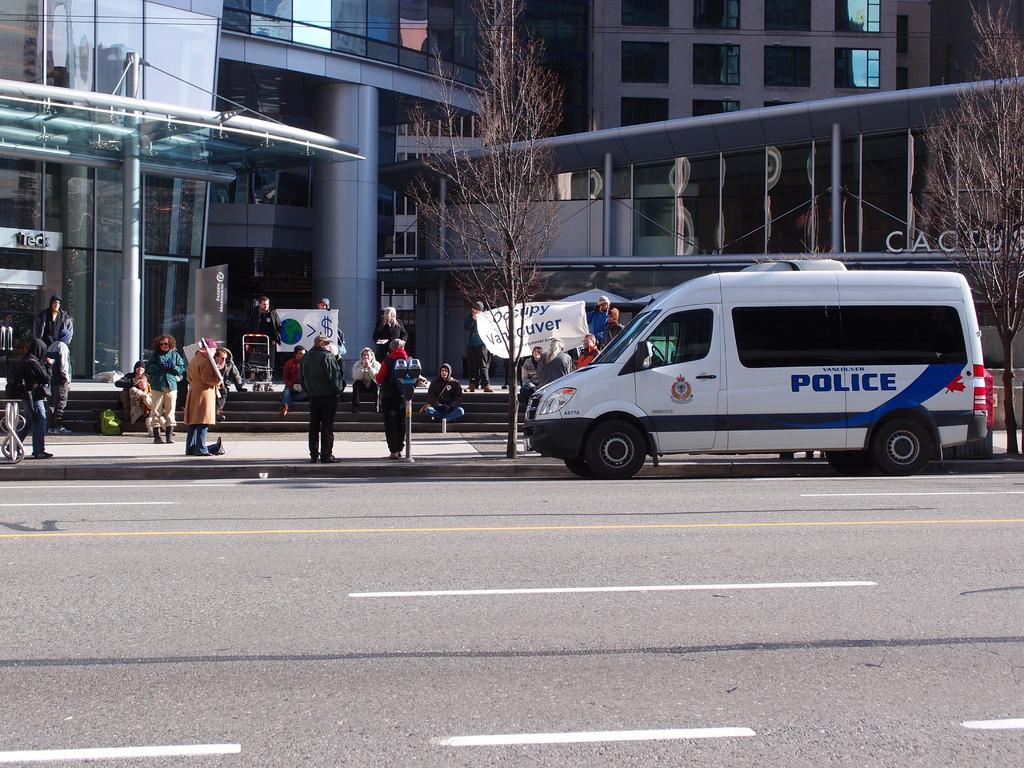Provide a one-sentence caption for the provided image. A white police van is parked in front of a group of protesters. 